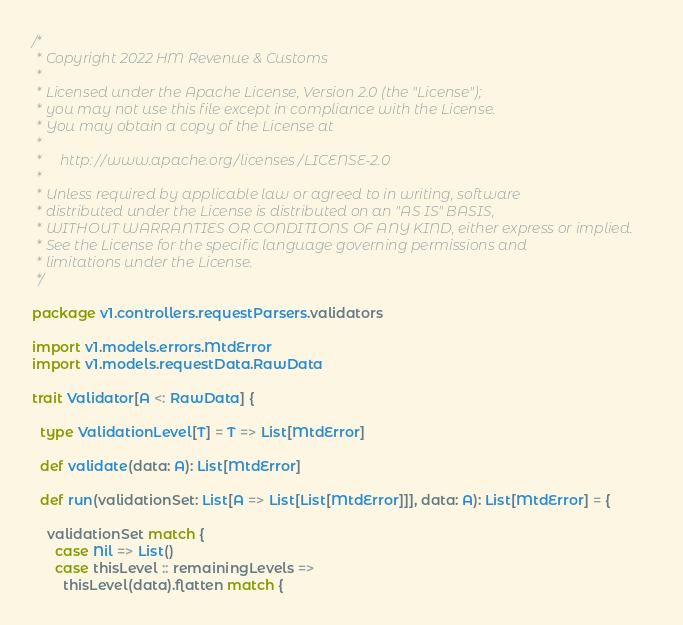<code> <loc_0><loc_0><loc_500><loc_500><_Scala_>/*
 * Copyright 2022 HM Revenue & Customs
 *
 * Licensed under the Apache License, Version 2.0 (the "License");
 * you may not use this file except in compliance with the License.
 * You may obtain a copy of the License at
 *
 *     http://www.apache.org/licenses/LICENSE-2.0
 *
 * Unless required by applicable law or agreed to in writing, software
 * distributed under the License is distributed on an "AS IS" BASIS,
 * WITHOUT WARRANTIES OR CONDITIONS OF ANY KIND, either express or implied.
 * See the License for the specific language governing permissions and
 * limitations under the License.
 */

package v1.controllers.requestParsers.validators

import v1.models.errors.MtdError
import v1.models.requestData.RawData

trait Validator[A <: RawData] {

  type ValidationLevel[T] = T => List[MtdError]

  def validate(data: A): List[MtdError]

  def run(validationSet: List[A => List[List[MtdError]]], data: A): List[MtdError] = {

    validationSet match {
      case Nil => List()
      case thisLevel :: remainingLevels =>
        thisLevel(data).flatten match {</code> 